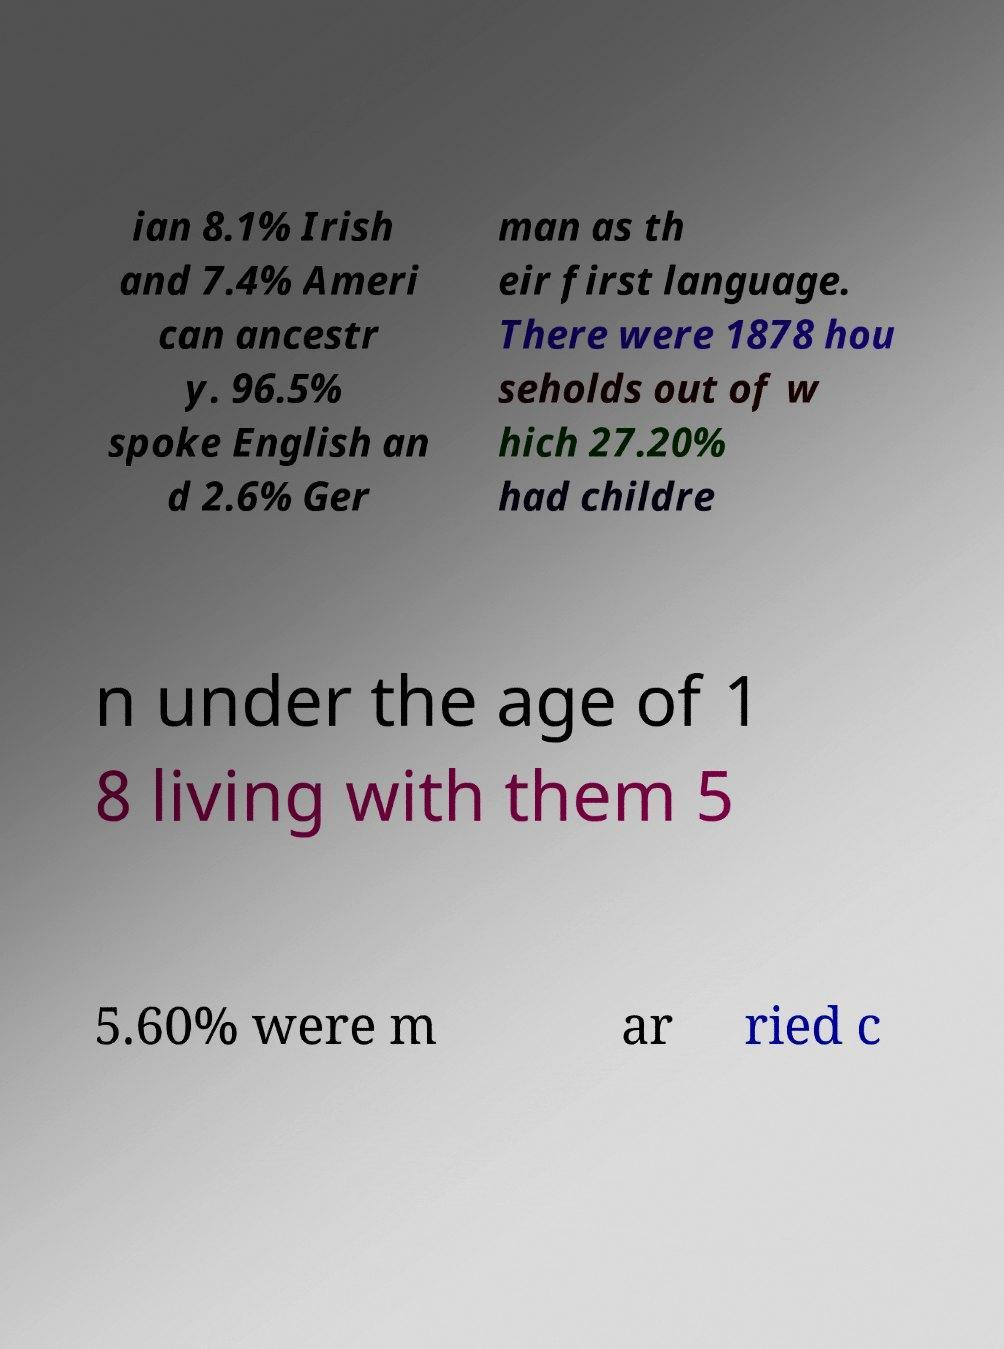Please identify and transcribe the text found in this image. ian 8.1% Irish and 7.4% Ameri can ancestr y. 96.5% spoke English an d 2.6% Ger man as th eir first language. There were 1878 hou seholds out of w hich 27.20% had childre n under the age of 1 8 living with them 5 5.60% were m ar ried c 